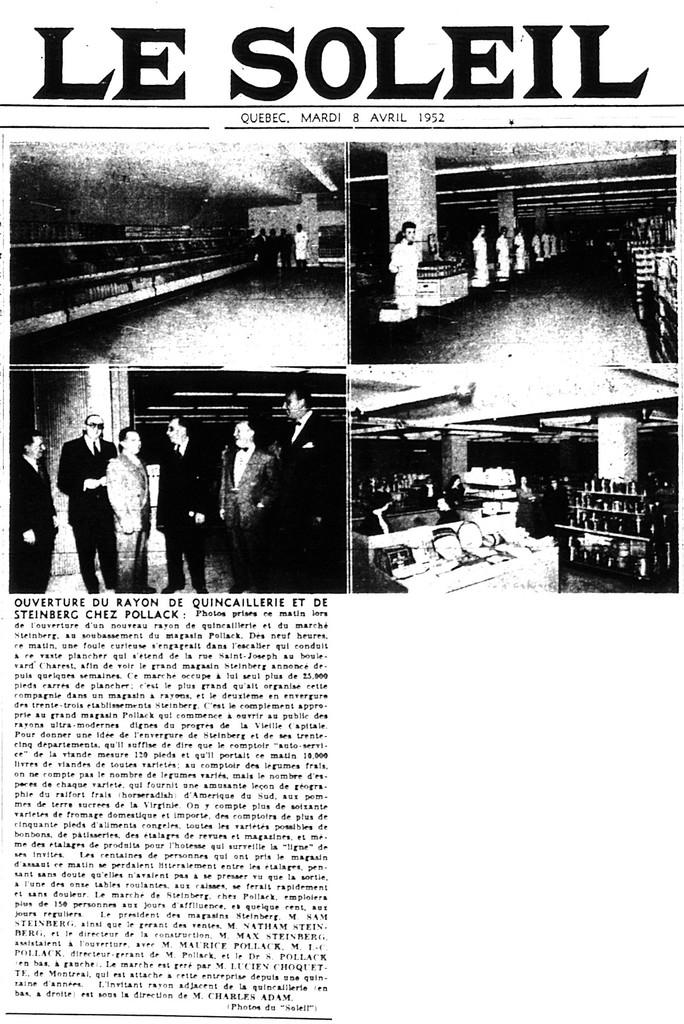What is the main subject of the image? The main subject of the image is an article. What type of content is included in the article? The article contains images of people. Is there any text present in the image? Yes, there is there is text written on the article. What type of humor can be found in the metal care instructions mentioned in the article? There are no metal care instructions or humor mentioned in the article, as the facts only describe an article with images of people and text. 